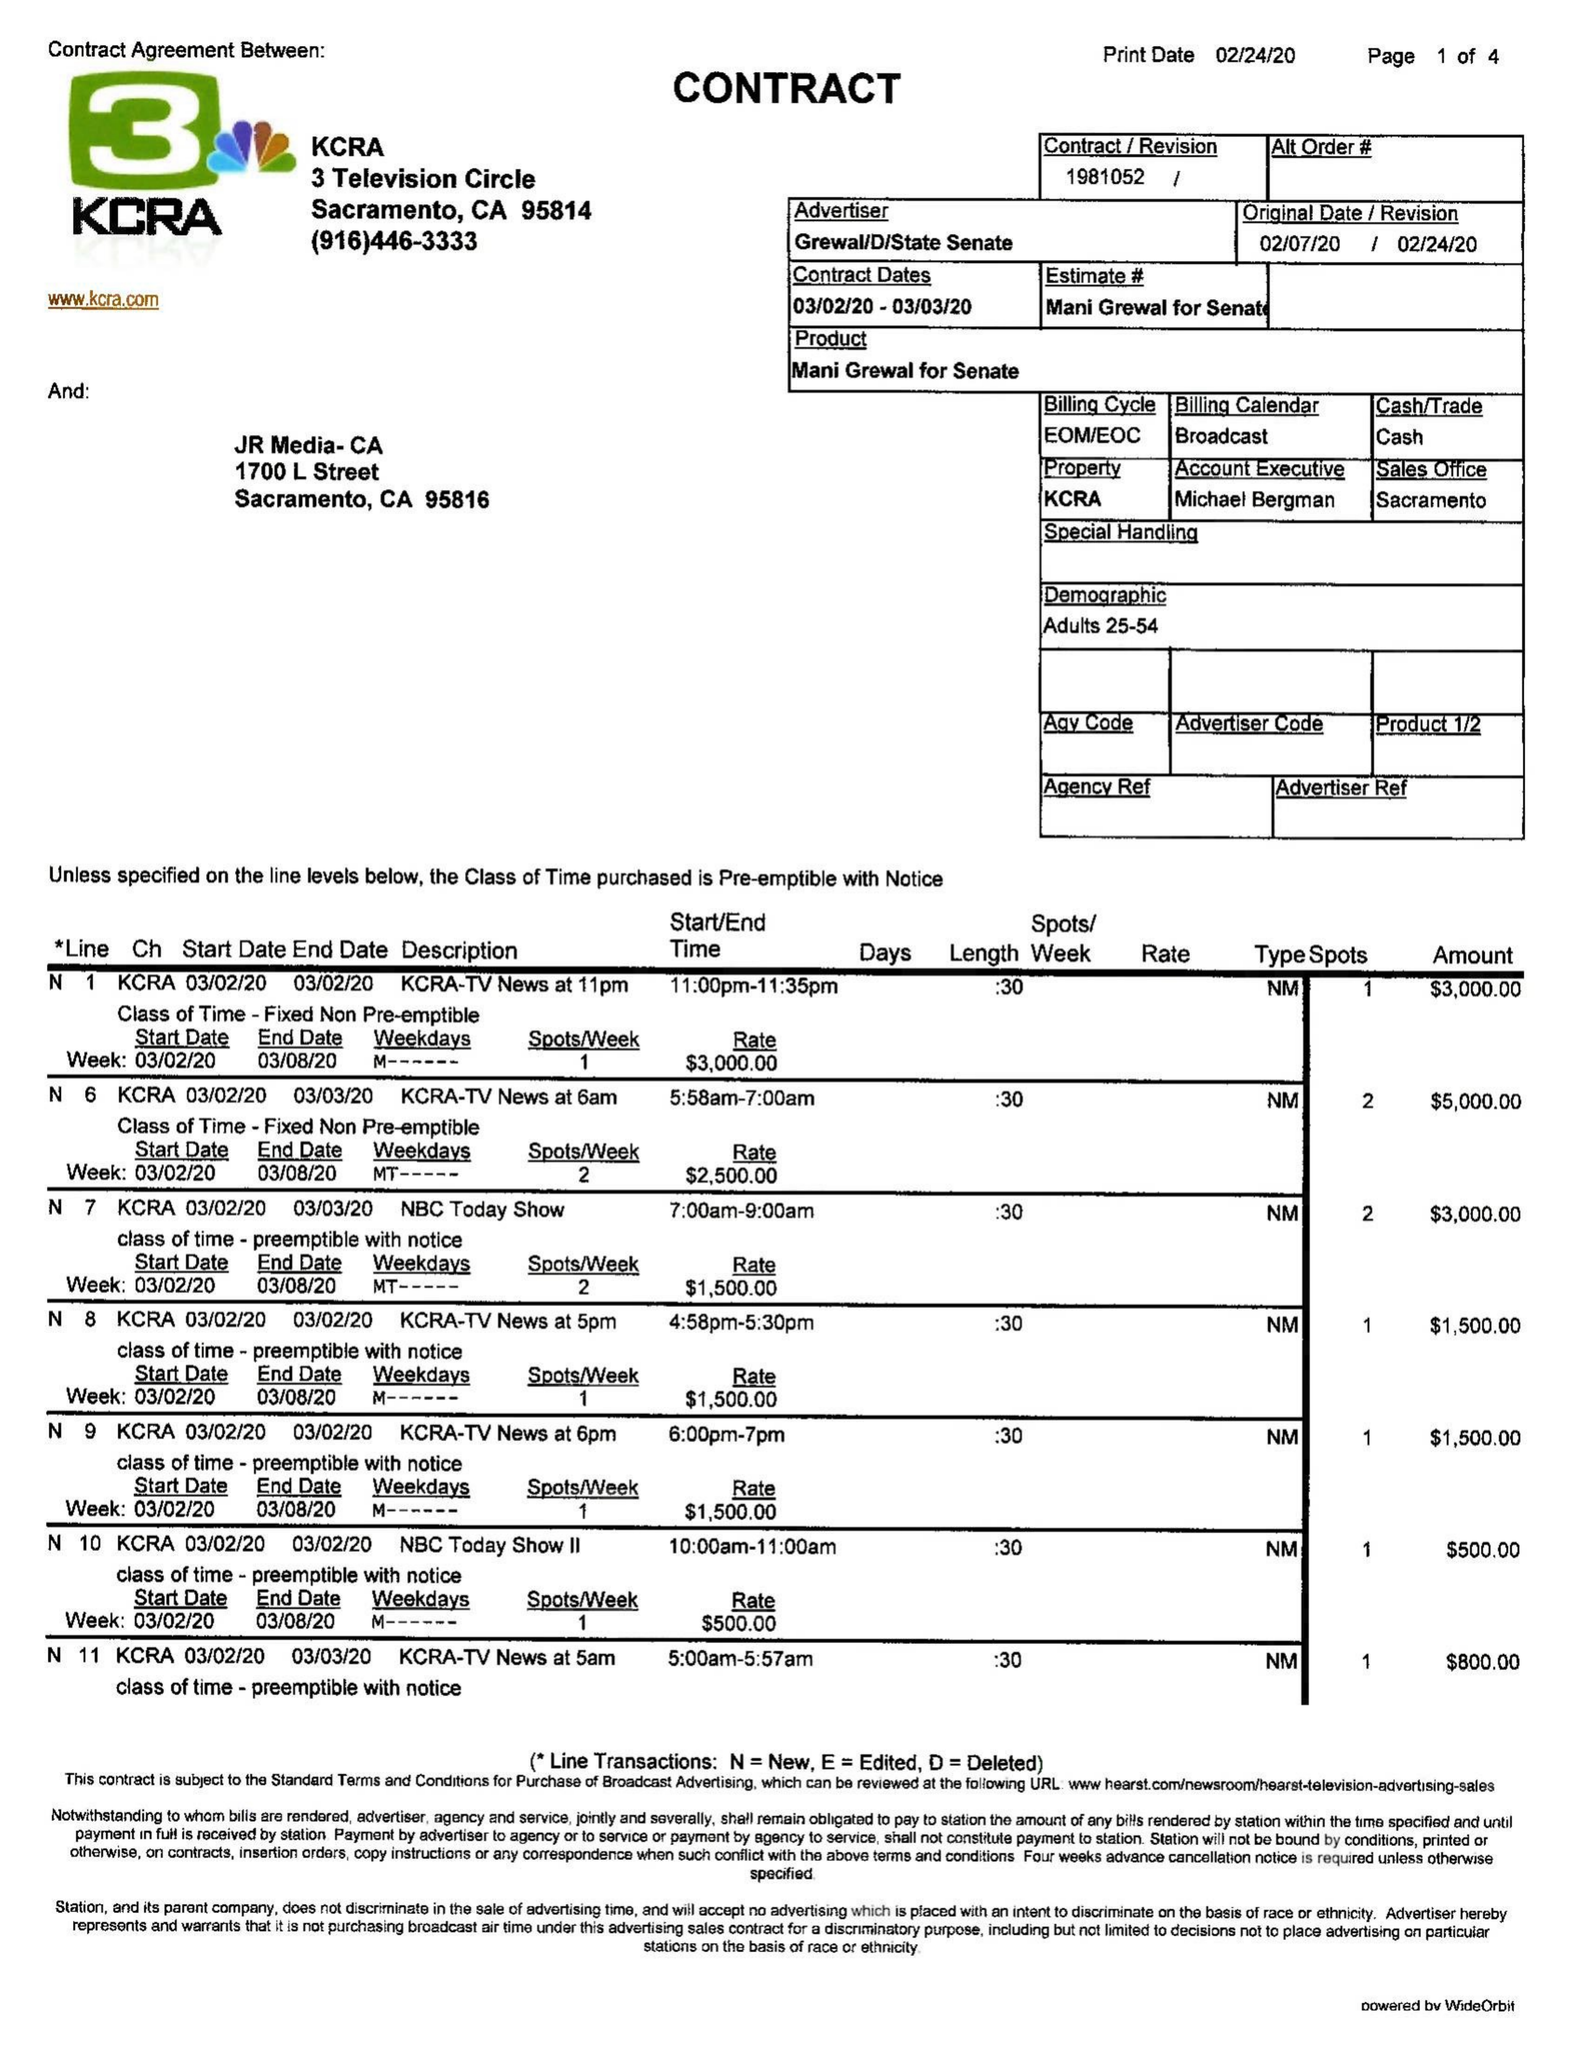What is the value for the gross_amount?
Answer the question using a single word or phrase. 15300.00 